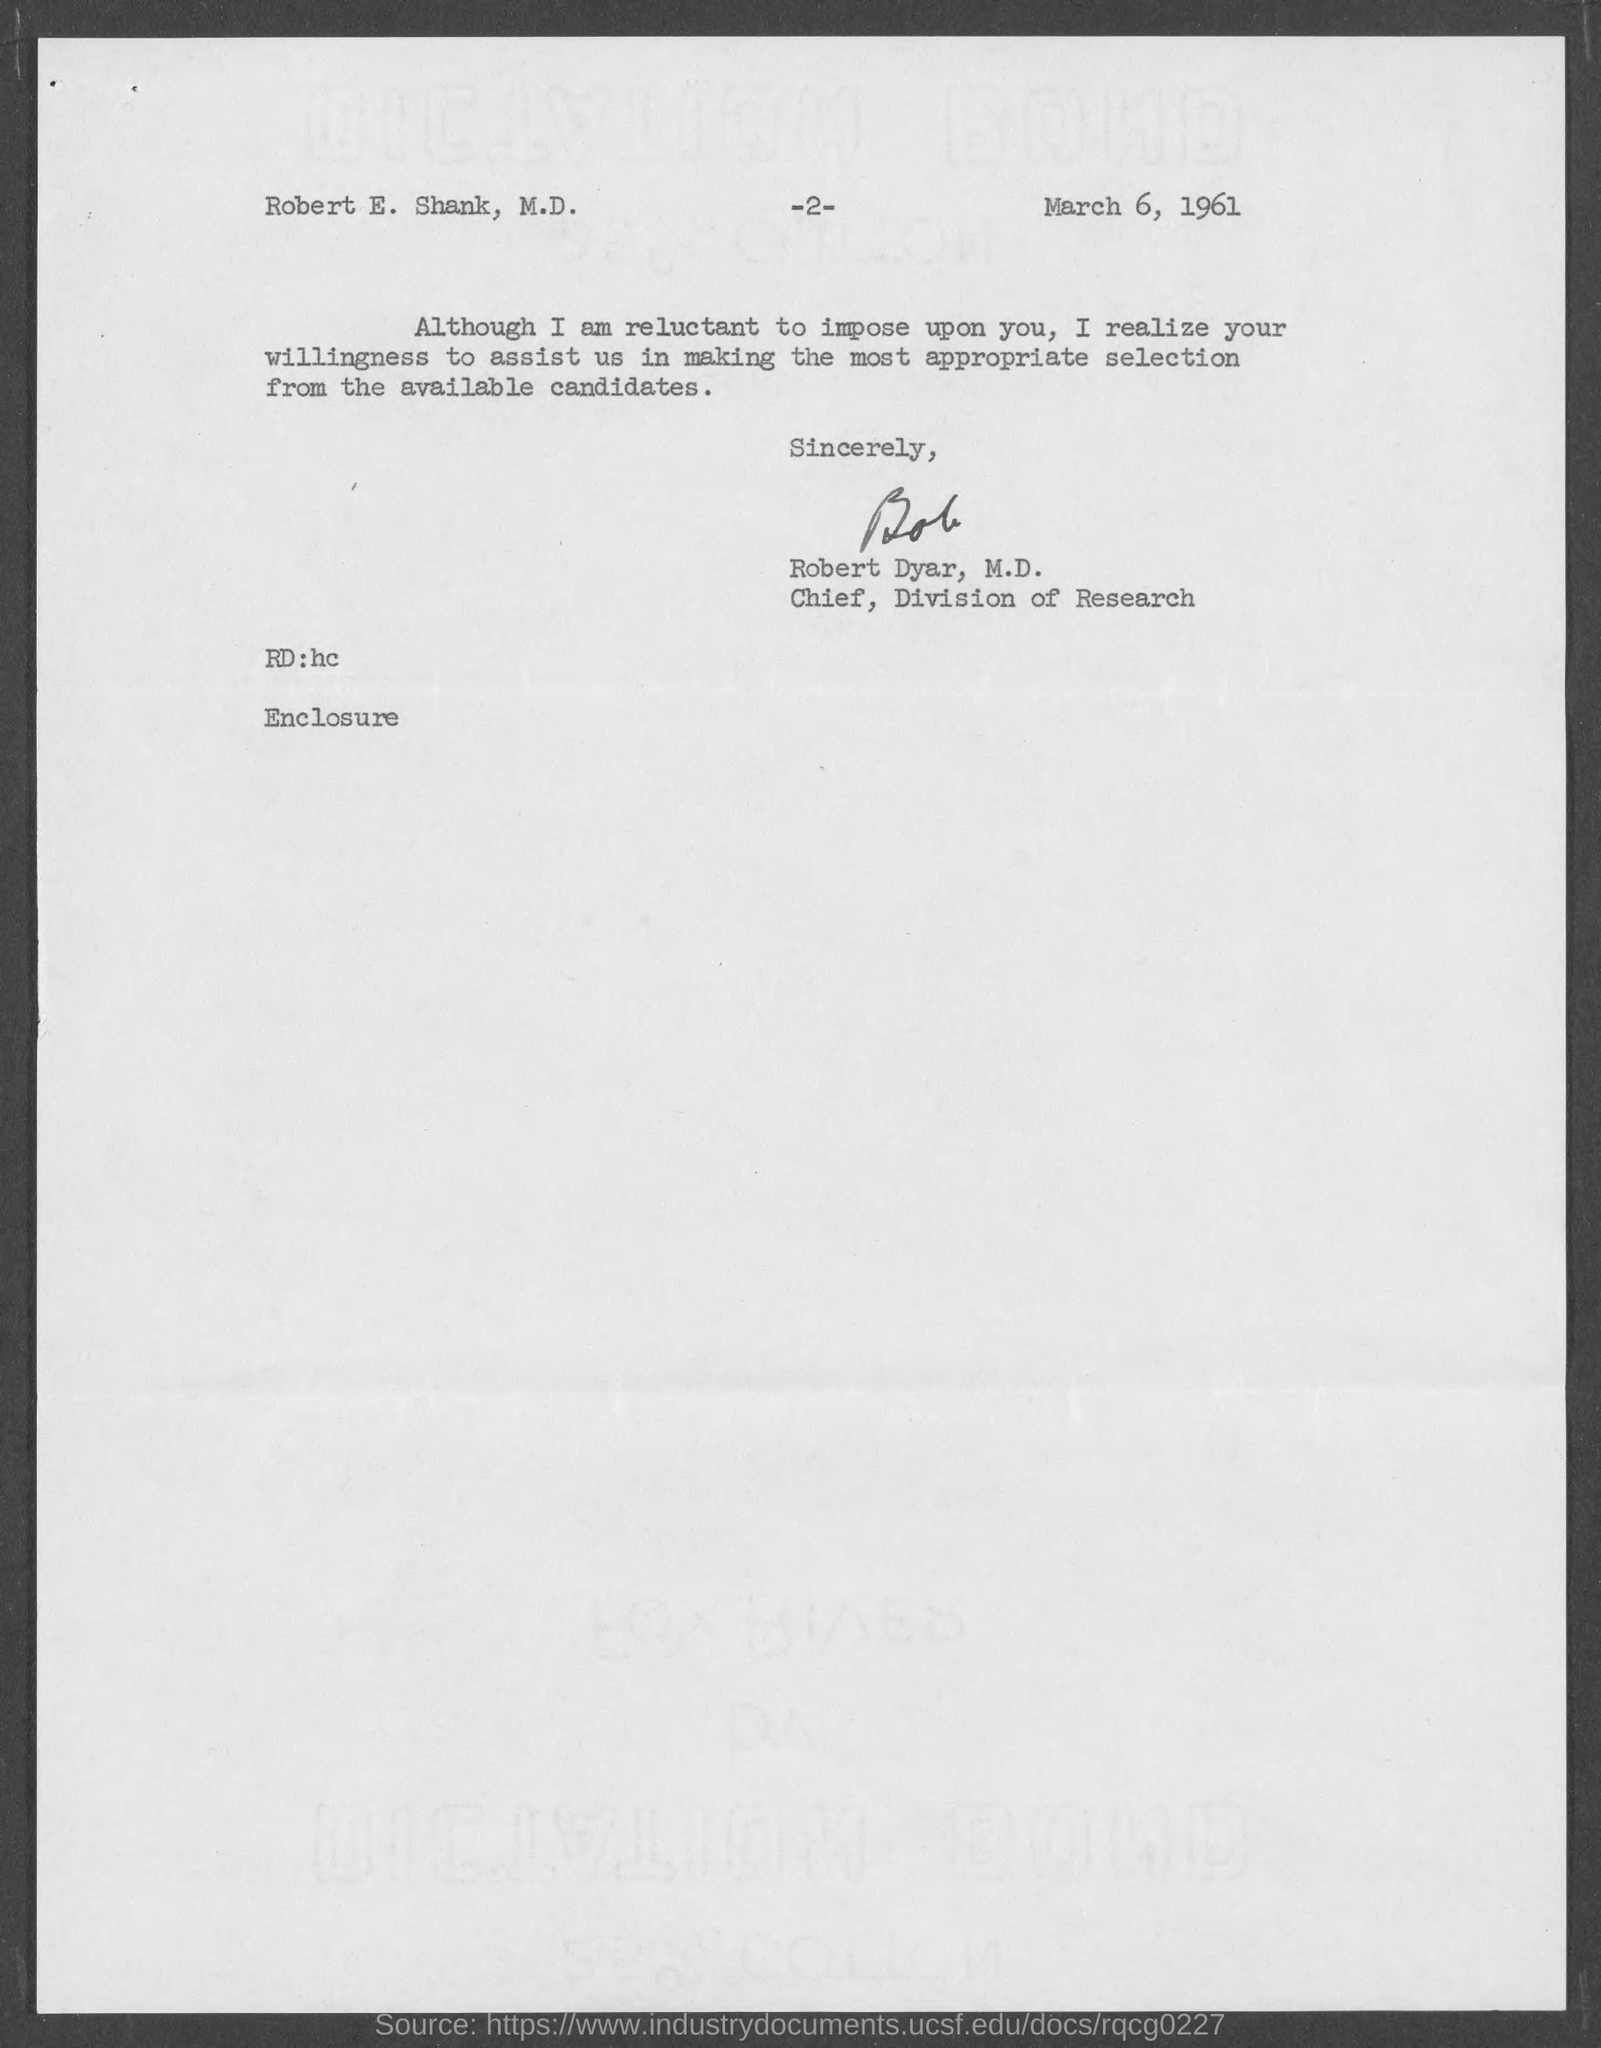Give some essential details in this illustration. The Chief of the Division of Research is Robert Dyar, M.D. The date mentioned in the document is March 6, 1961. The page number is 2, as declared. 